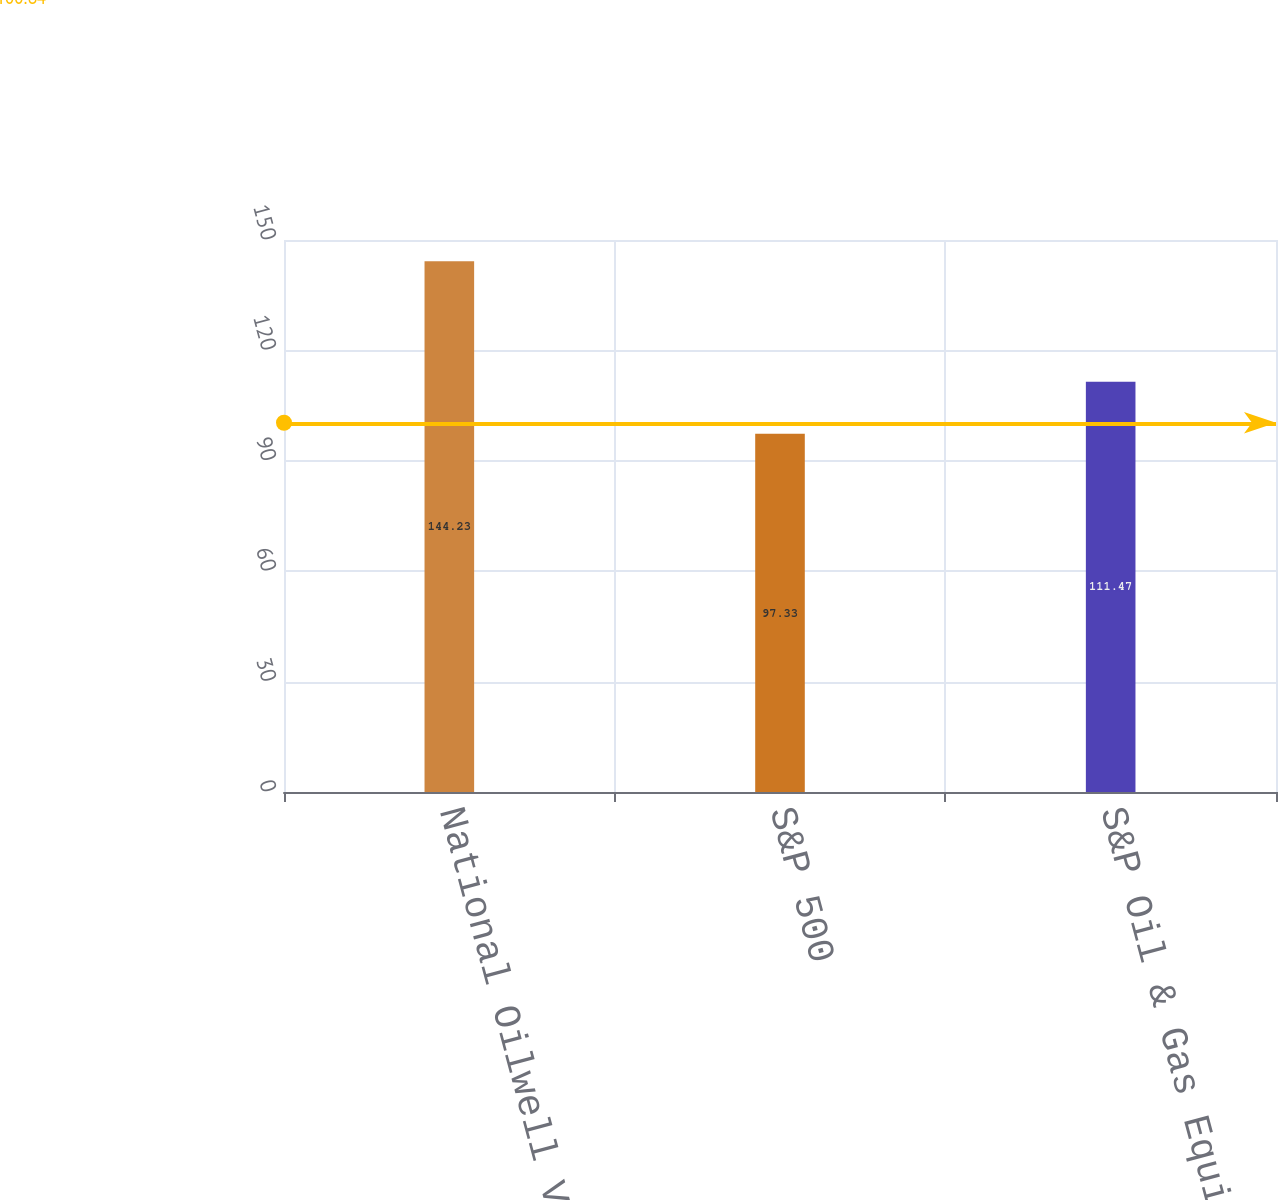Convert chart. <chart><loc_0><loc_0><loc_500><loc_500><bar_chart><fcel>National Oilwell Varco Inc<fcel>S&P 500<fcel>S&P Oil & Gas Equipment &<nl><fcel>144.23<fcel>97.33<fcel>111.47<nl></chart> 